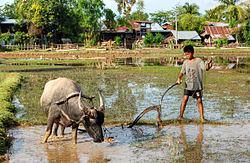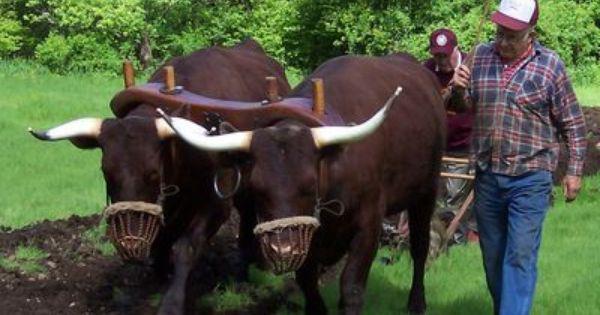The first image is the image on the left, the second image is the image on the right. Given the left and right images, does the statement "a pair of oxen are pulling a cart down a dirt path" hold true? Answer yes or no. No. The first image is the image on the left, the second image is the image on the right. Analyze the images presented: Is the assertion "The image on the right shows a single ox drawing a cart." valid? Answer yes or no. No. 